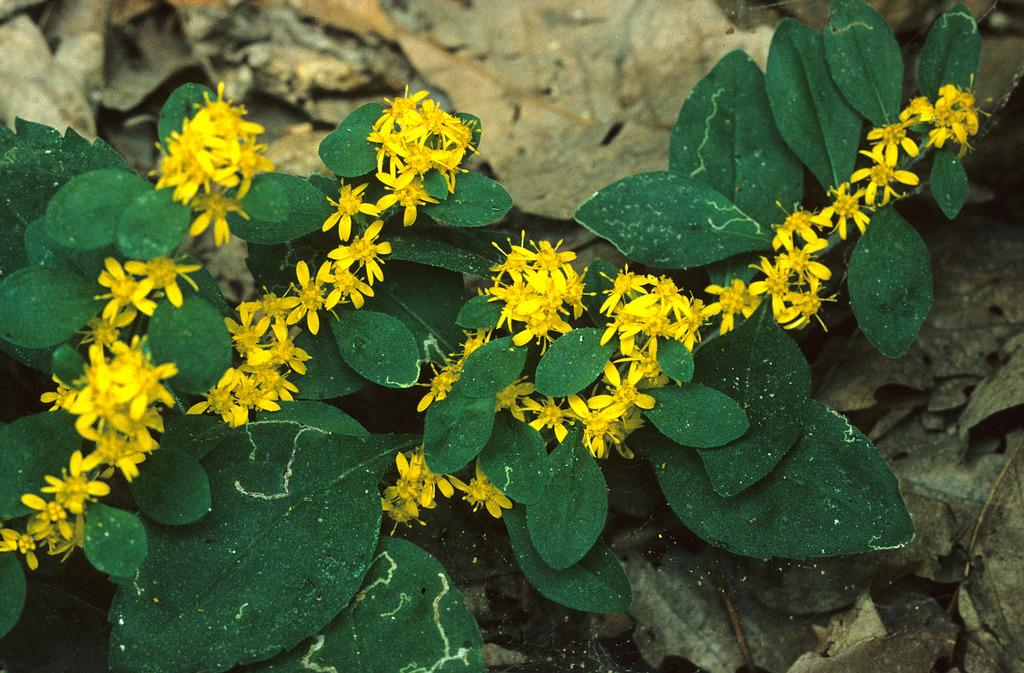What type of plant material can be seen in the image? There are dried leaves and green leaves in the image. What color are the flowers in the image? The flowers in the image are yellow. Where is the turkey located in the image? There is no turkey present in the image. What type of meat can be seen hanging from the bridge in the image? There is no bridge or meat present in the image. 